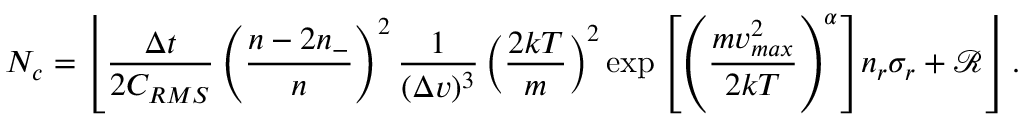<formula> <loc_0><loc_0><loc_500><loc_500>N _ { c } = \left \lfloor \frac { \Delta t } { 2 C _ { R M S } } \left ( \frac { n - 2 n _ { - } } { n } \right ) ^ { 2 } \frac { 1 } { ( \Delta v ) ^ { 3 } } \left ( \frac { 2 k T } { m } \right ) ^ { 2 } { \exp \left [ \left ( \frac { m v _ { \max } ^ { 2 } } { 2 k T } \right ) ^ { \alpha } \right ] } { n _ { r } \sigma _ { r } } + \mathcal { R } \right \rfloor .</formula> 